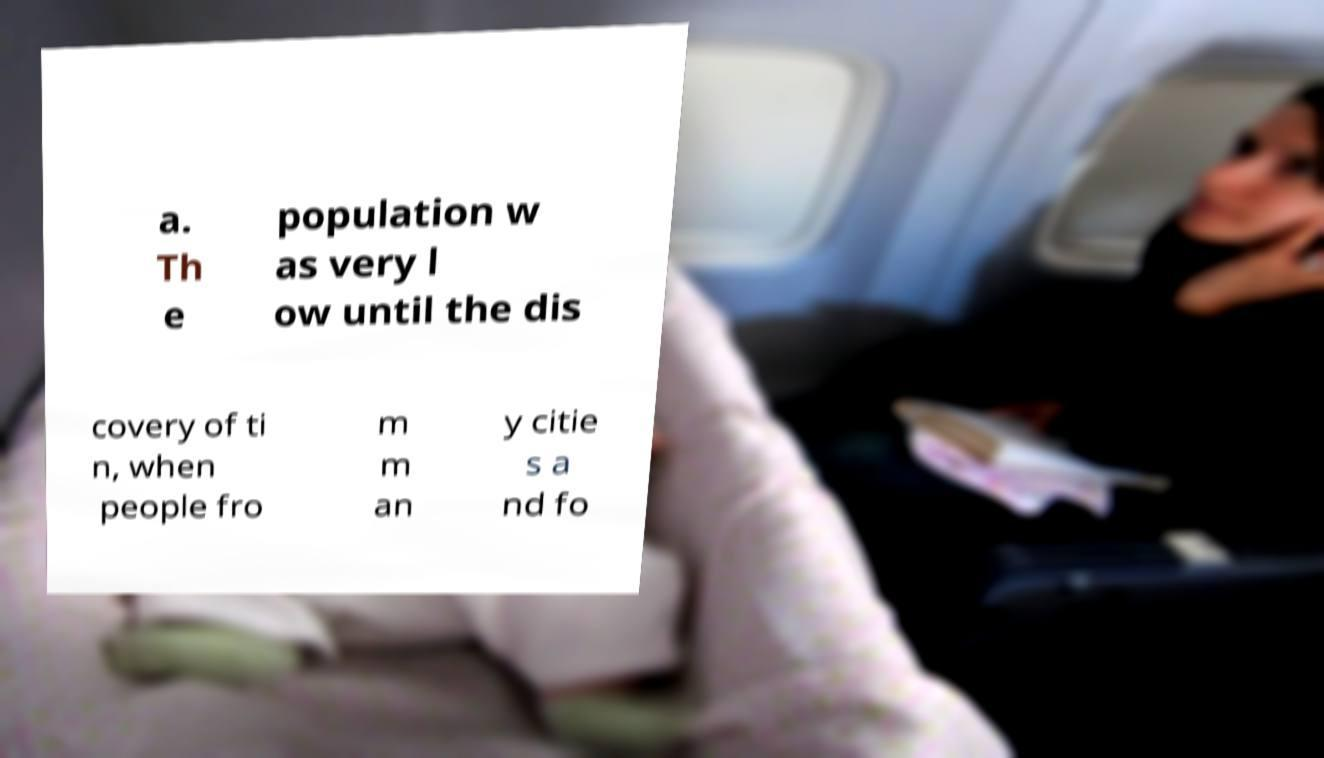What messages or text are displayed in this image? I need them in a readable, typed format. a. Th e population w as very l ow until the dis covery of ti n, when people fro m m an y citie s a nd fo 